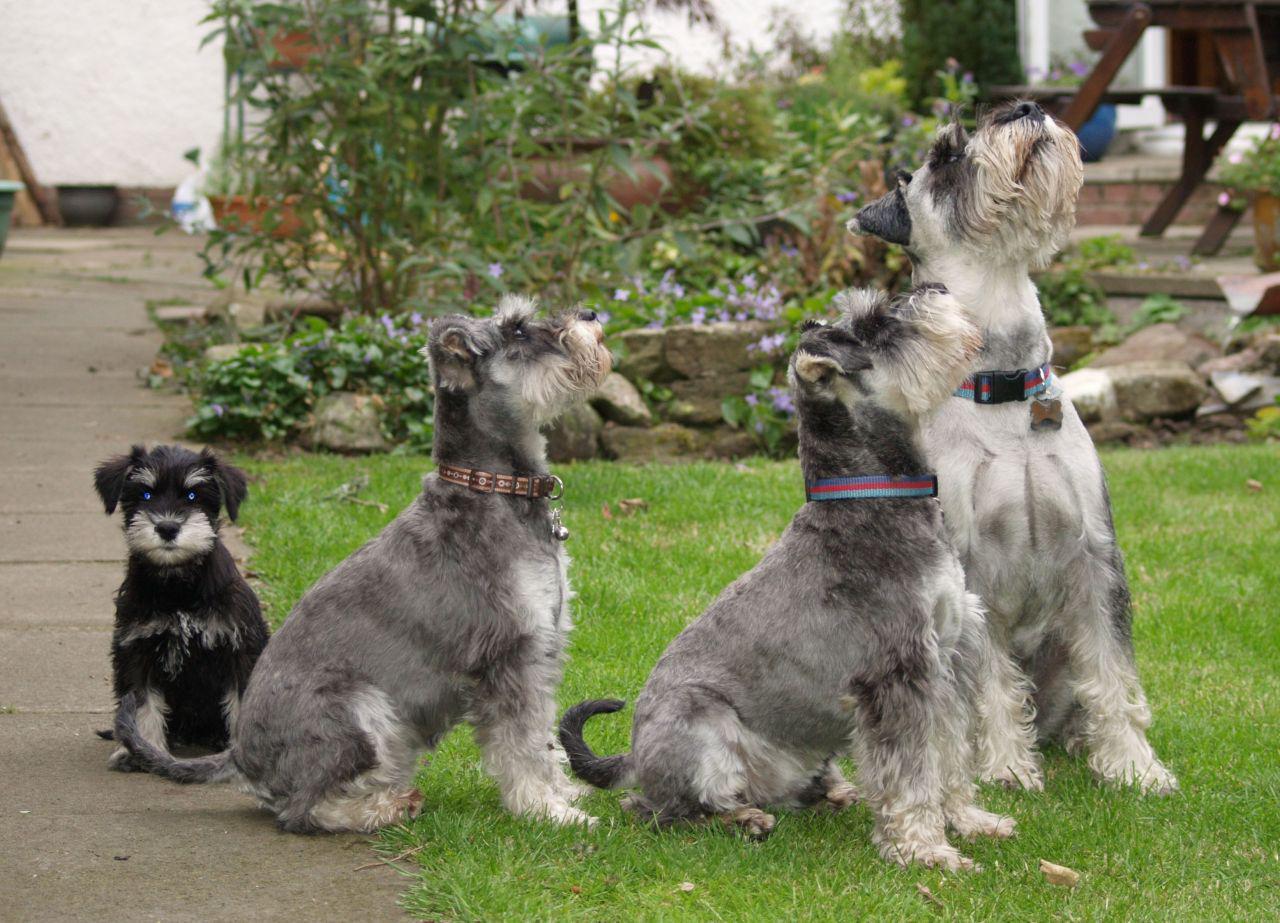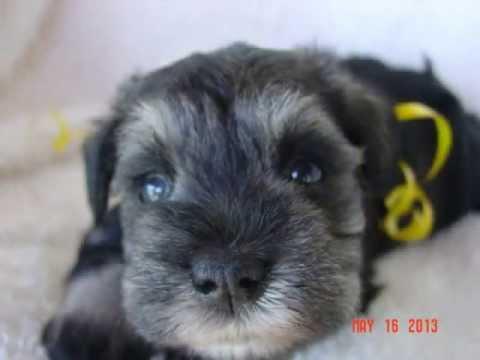The first image is the image on the left, the second image is the image on the right. Examine the images to the left and right. Is the description "The combined images contain five schnauzers, and at least four are sitting upright." accurate? Answer yes or no. Yes. The first image is the image on the left, the second image is the image on the right. For the images displayed, is the sentence "The left image contains at least three dogs." factually correct? Answer yes or no. Yes. 